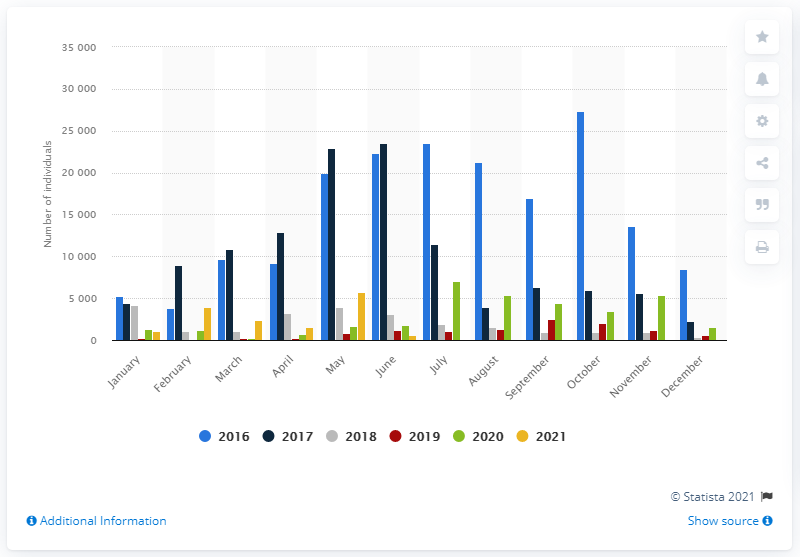List a handful of essential elements in this visual. In July of 2020, there were approximately 7,067 people who stepped foot in Italy. In October 2016, a total of 27,384 people crossed the Mediterranean Sea. The highest number of migrants arrived in Italy by sea in the month of February. 